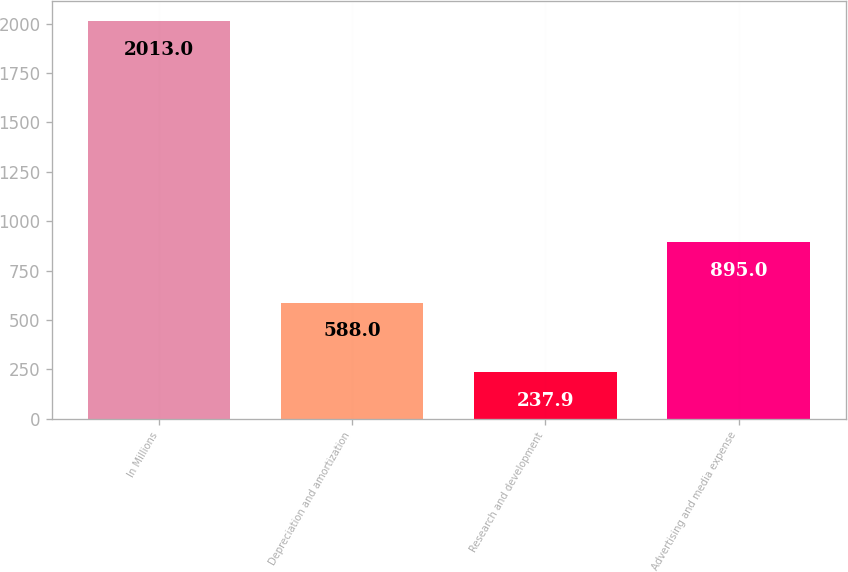<chart> <loc_0><loc_0><loc_500><loc_500><bar_chart><fcel>In Millions<fcel>Depreciation and amortization<fcel>Research and development<fcel>Advertising and media expense<nl><fcel>2013<fcel>588<fcel>237.9<fcel>895<nl></chart> 